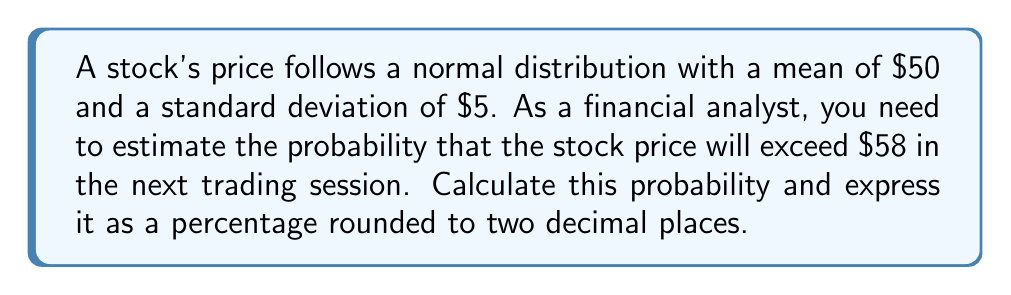Solve this math problem. To solve this problem, we'll follow these steps:

1) First, we need to standardize the given value to calculate the z-score:

   $$z = \frac{x - \mu}{\sigma}$$

   Where:
   $x$ is the threshold value ($58)
   $\mu$ is the mean ($50)
   $\sigma$ is the standard deviation ($5)

2) Plugging in the values:

   $$z = \frac{58 - 50}{5} = \frac{8}{5} = 1.6$$

3) Now, we need to find the probability of a value being greater than this z-score. This is equivalent to finding the area under the standard normal curve to the right of z = 1.6.

4) Using a standard normal table or a statistical software, we can find that:

   $$P(Z > 1.6) \approx 0.0548$$

5) To convert this to a percentage, we multiply by 100:

   $$0.0548 \times 100 = 5.48\%$$

6) Rounding to two decimal places gives us 5.48%.

This means there's approximately a 5.48% chance that the stock price will exceed $58 in the next trading session, given the assumed normal distribution of the stock price.
Answer: 5.48% 